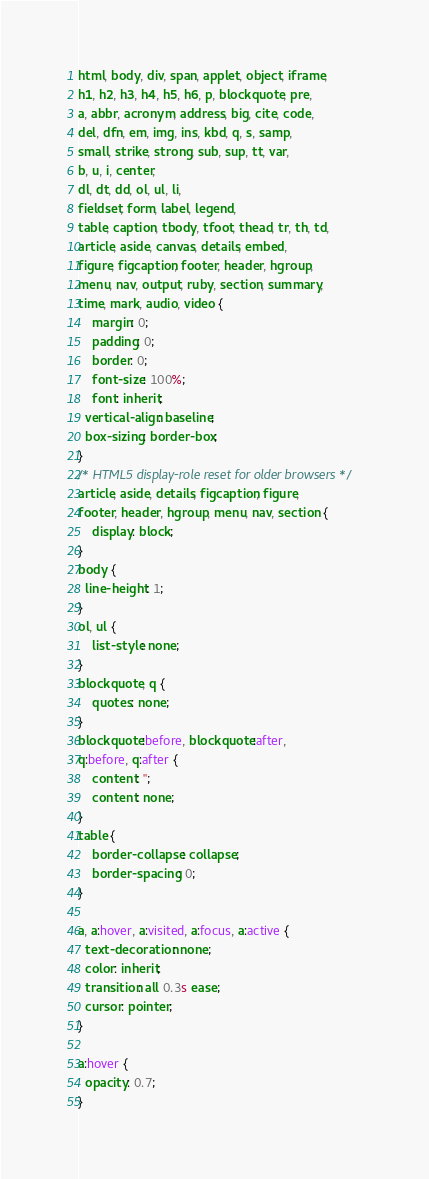<code> <loc_0><loc_0><loc_500><loc_500><_CSS_>
html, body, div, span, applet, object, iframe,
h1, h2, h3, h4, h5, h6, p, blockquote, pre,
a, abbr, acronym, address, big, cite, code,
del, dfn, em, img, ins, kbd, q, s, samp,
small, strike, strong, sub, sup, tt, var,
b, u, i, center,
dl, dt, dd, ol, ul, li,
fieldset, form, label, legend,
table, caption, tbody, tfoot, thead, tr, th, td,
article, aside, canvas, details, embed, 
figure, figcaption, footer, header, hgroup, 
menu, nav, output, ruby, section, summary,
time, mark, audio, video {
	margin: 0;
	padding: 0;
	border: 0;
	font-size: 100%;
	font: inherit;
  vertical-align: baseline;
  box-sizing: border-box;
}
/* HTML5 display-role reset for older browsers */
article, aside, details, figcaption, figure, 
footer, header, hgroup, menu, nav, section {
	display: block;
}
body {
  line-height: 1;
}
ol, ul {
	list-style: none;
}
blockquote, q {
	quotes: none;
}
blockquote:before, blockquote:after,
q:before, q:after {
	content: '';
	content: none;
}
table {
	border-collapse: collapse;
	border-spacing: 0;
}

a, a:hover, a:visited, a:focus, a:active {
  text-decoration: none;
  color: inherit;
  transition: all 0.3s ease;
  cursor: pointer;
}

a:hover {
  opacity: 0.7;
}</code> 